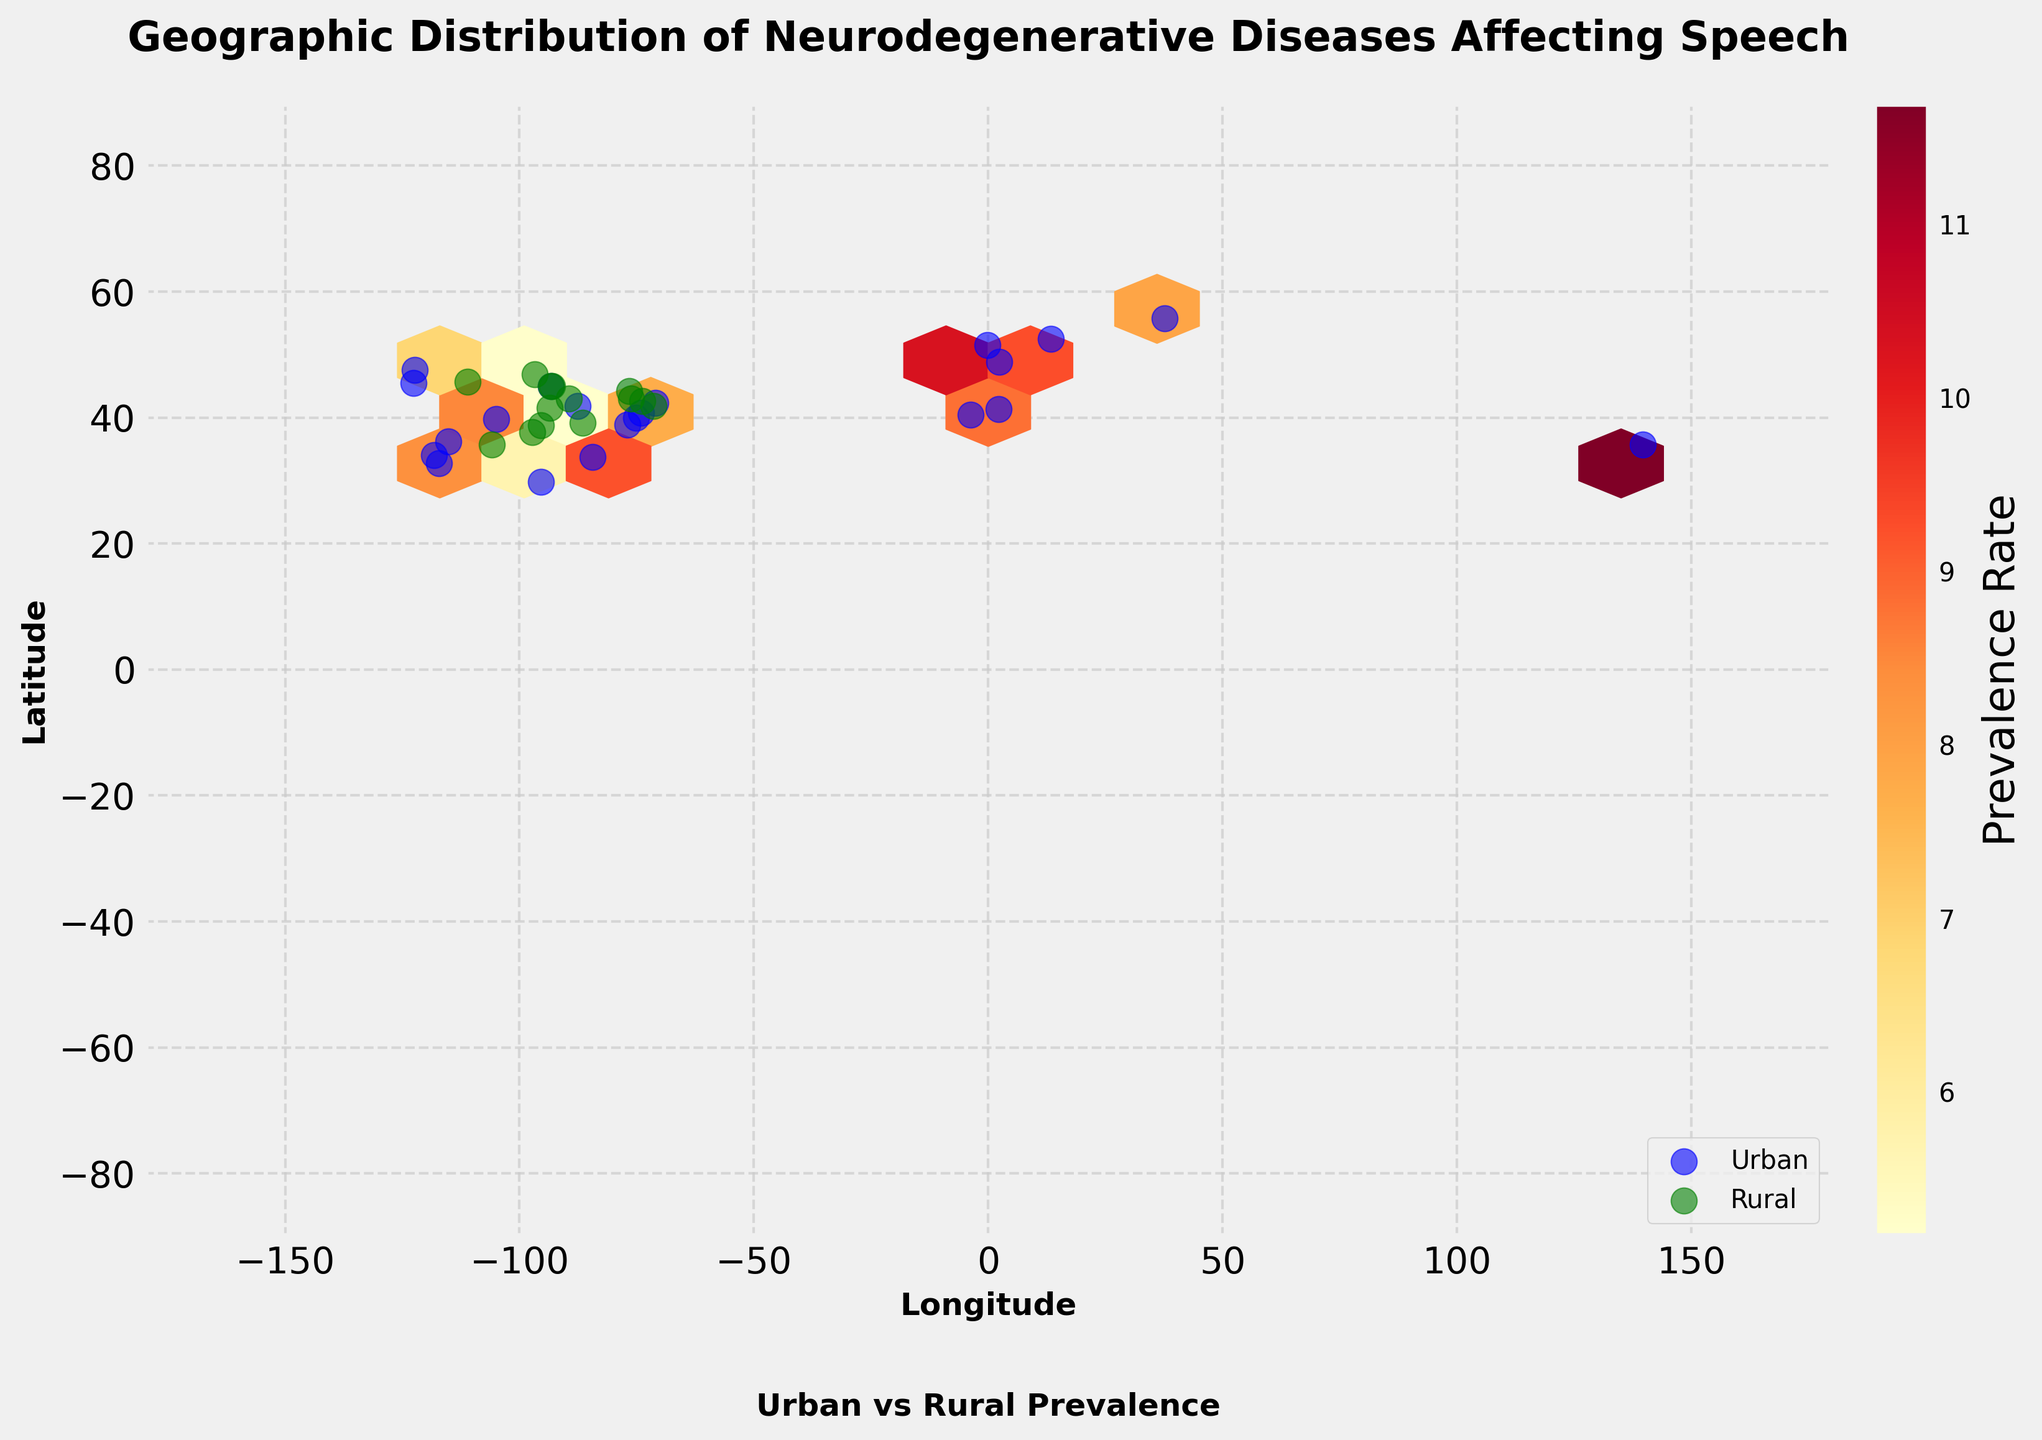How are urban and rural areas distinguished on the plot? Urban areas are marked with blue dots, while rural areas are marked with green dots. This differentiation is seen in the legend at the lower right of the plot.
Answer: By color: urban in blue, rural in green What are the axes labels on the plot? The x-axis is labeled 'Longitude' and the y-axis is labeled 'Latitude'. These labels are found at the bottom and left of the plot, respectively.
Answer: Longitude (x-axis) and Latitude (y-axis) Based on the color scale, which areas have the highest prevalence rates of neurodegenerative diseases? The color scale ranges from light yellow to dark red, with darker shades indicating higher prevalence rates. Urban areas tend to be located in these darker regions, especially on the east and west coasts of the US.
Answer: Urban areas, especially on US coasts How does the prevalence rate in urban areas compare to rural areas in general? By looking at the hexbin color distribution and the location of urban and rural dots, urban areas generally exhibit darker hexagons (higher prevalence rates), while rural areas tend to be in lighter hexagons (lower prevalence rates).
Answer: Urban areas have higher prevalence rates Which major cities exhibit the highest prevalence rates for specific diseases? Cities such as New York, Tokyo, and Boston show very dark hexagons, indicating high prevalence rates. For instance, New York for Progressive Supranuclear Palsy or Tokyo for Multiple System Atrophy.
Answer: New York, Tokyo, Boston What is the prevalent geographic distribution pattern for diseases affecting speech? The plot shows a higher concentration of urban areas with high prevalence on the east and west coasts of the US and some key international cities. Rural areas, scattered more uniformly, show generally lower prevalence rates.
Answer: High prevalence in major urban areas, lower in rural Which type of area (urban or rural) has more data points plotted on the chart? The urban areas have more data points as evidenced by the higher number of blue dots compared to green dots for rural areas.
Answer: Urban areas Are there any regions with very low prevalence rates? If so, which? Low prevalence rates are indicated by very light yellow hexagons. Rural areas in the central US, such as around Kansas and Montana, exhibit these low prevalence rates.
Answer: Central US rural areas Among the diseases listed, which appears to have the highest urban-rural prevalence disparity? Examining the distribution, Progressive Supranuclear Palsy in New York (12.3) vs. a rural area in Syracuse (5.7) shows a significant disparity, almost twice as much in urban areas.
Answer: Progressive Supranuclear Palsy 